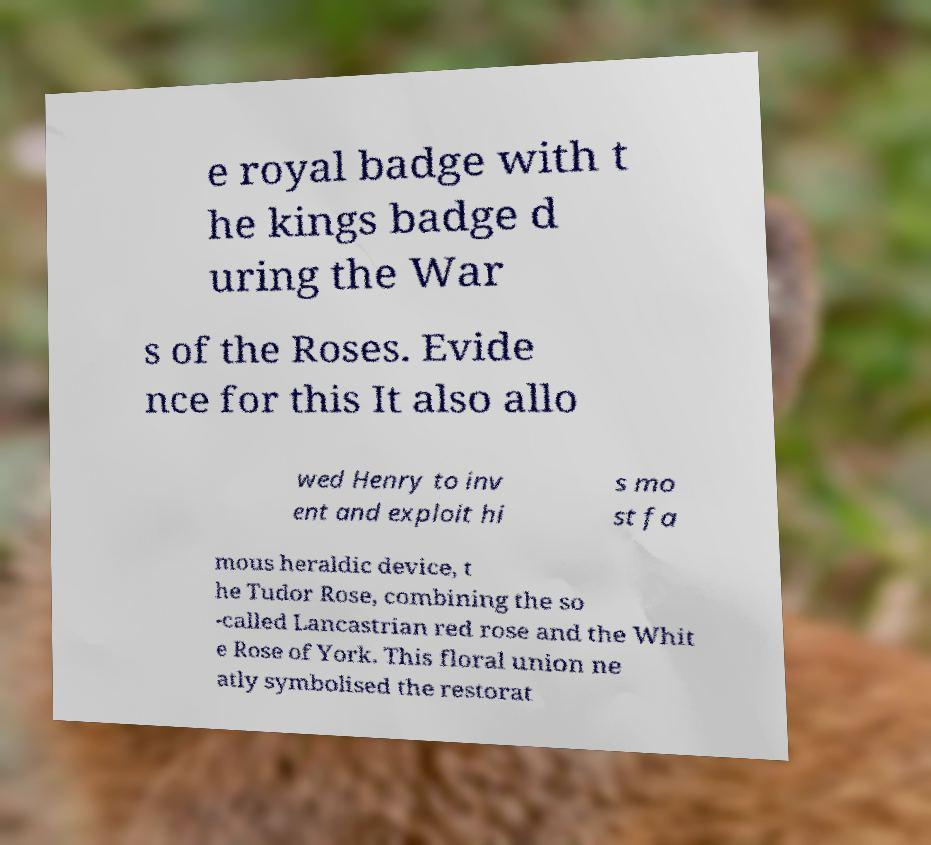There's text embedded in this image that I need extracted. Can you transcribe it verbatim? e royal badge with t he kings badge d uring the War s of the Roses. Evide nce for this It also allo wed Henry to inv ent and exploit hi s mo st fa mous heraldic device, t he Tudor Rose, combining the so -called Lancastrian red rose and the Whit e Rose of York. This floral union ne atly symbolised the restorat 